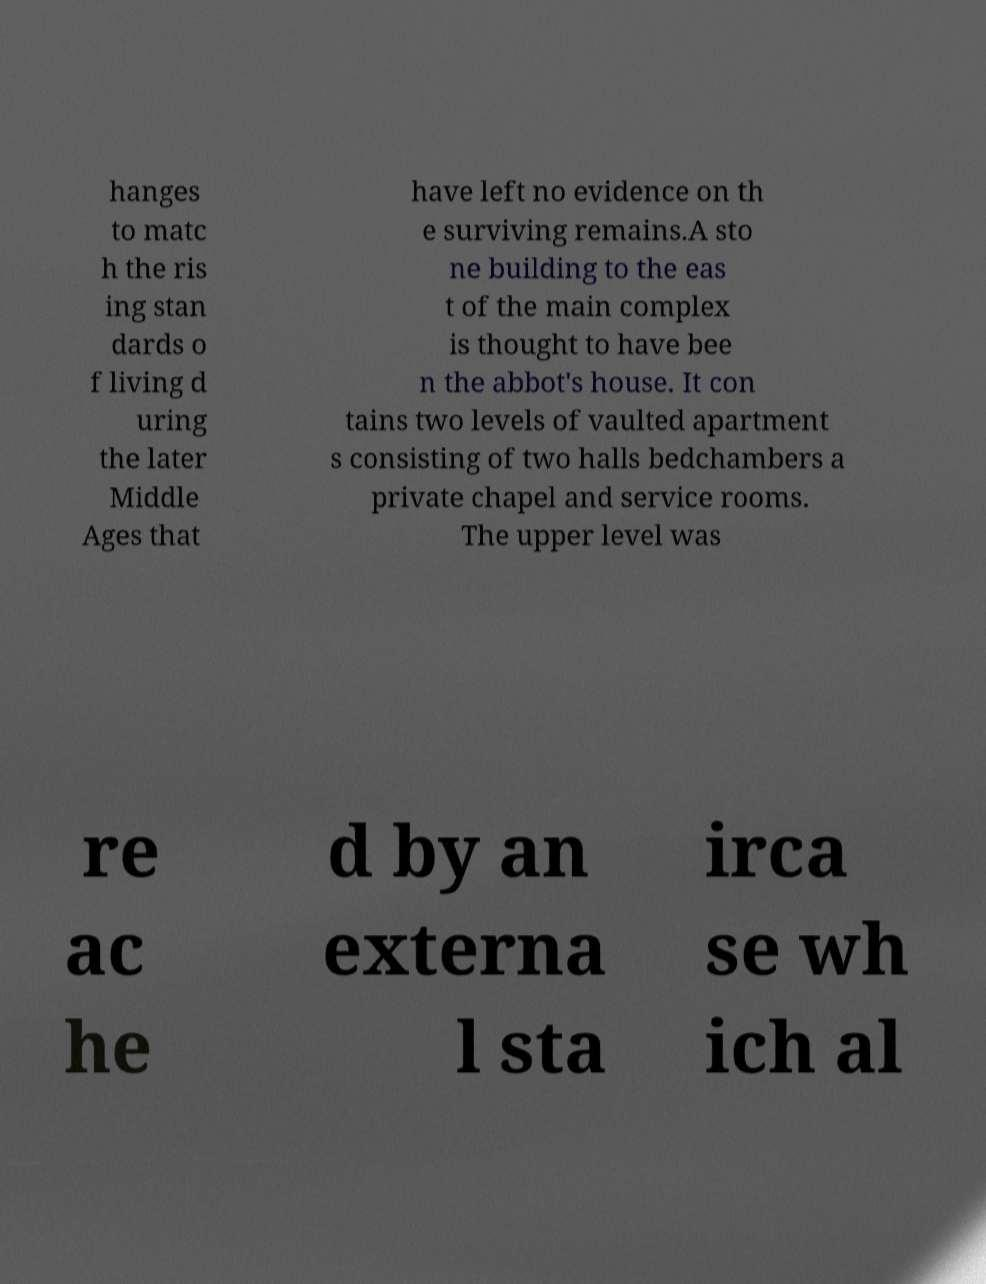Please identify and transcribe the text found in this image. hanges to matc h the ris ing stan dards o f living d uring the later Middle Ages that have left no evidence on th e surviving remains.A sto ne building to the eas t of the main complex is thought to have bee n the abbot's house. It con tains two levels of vaulted apartment s consisting of two halls bedchambers a private chapel and service rooms. The upper level was re ac he d by an externa l sta irca se wh ich al 